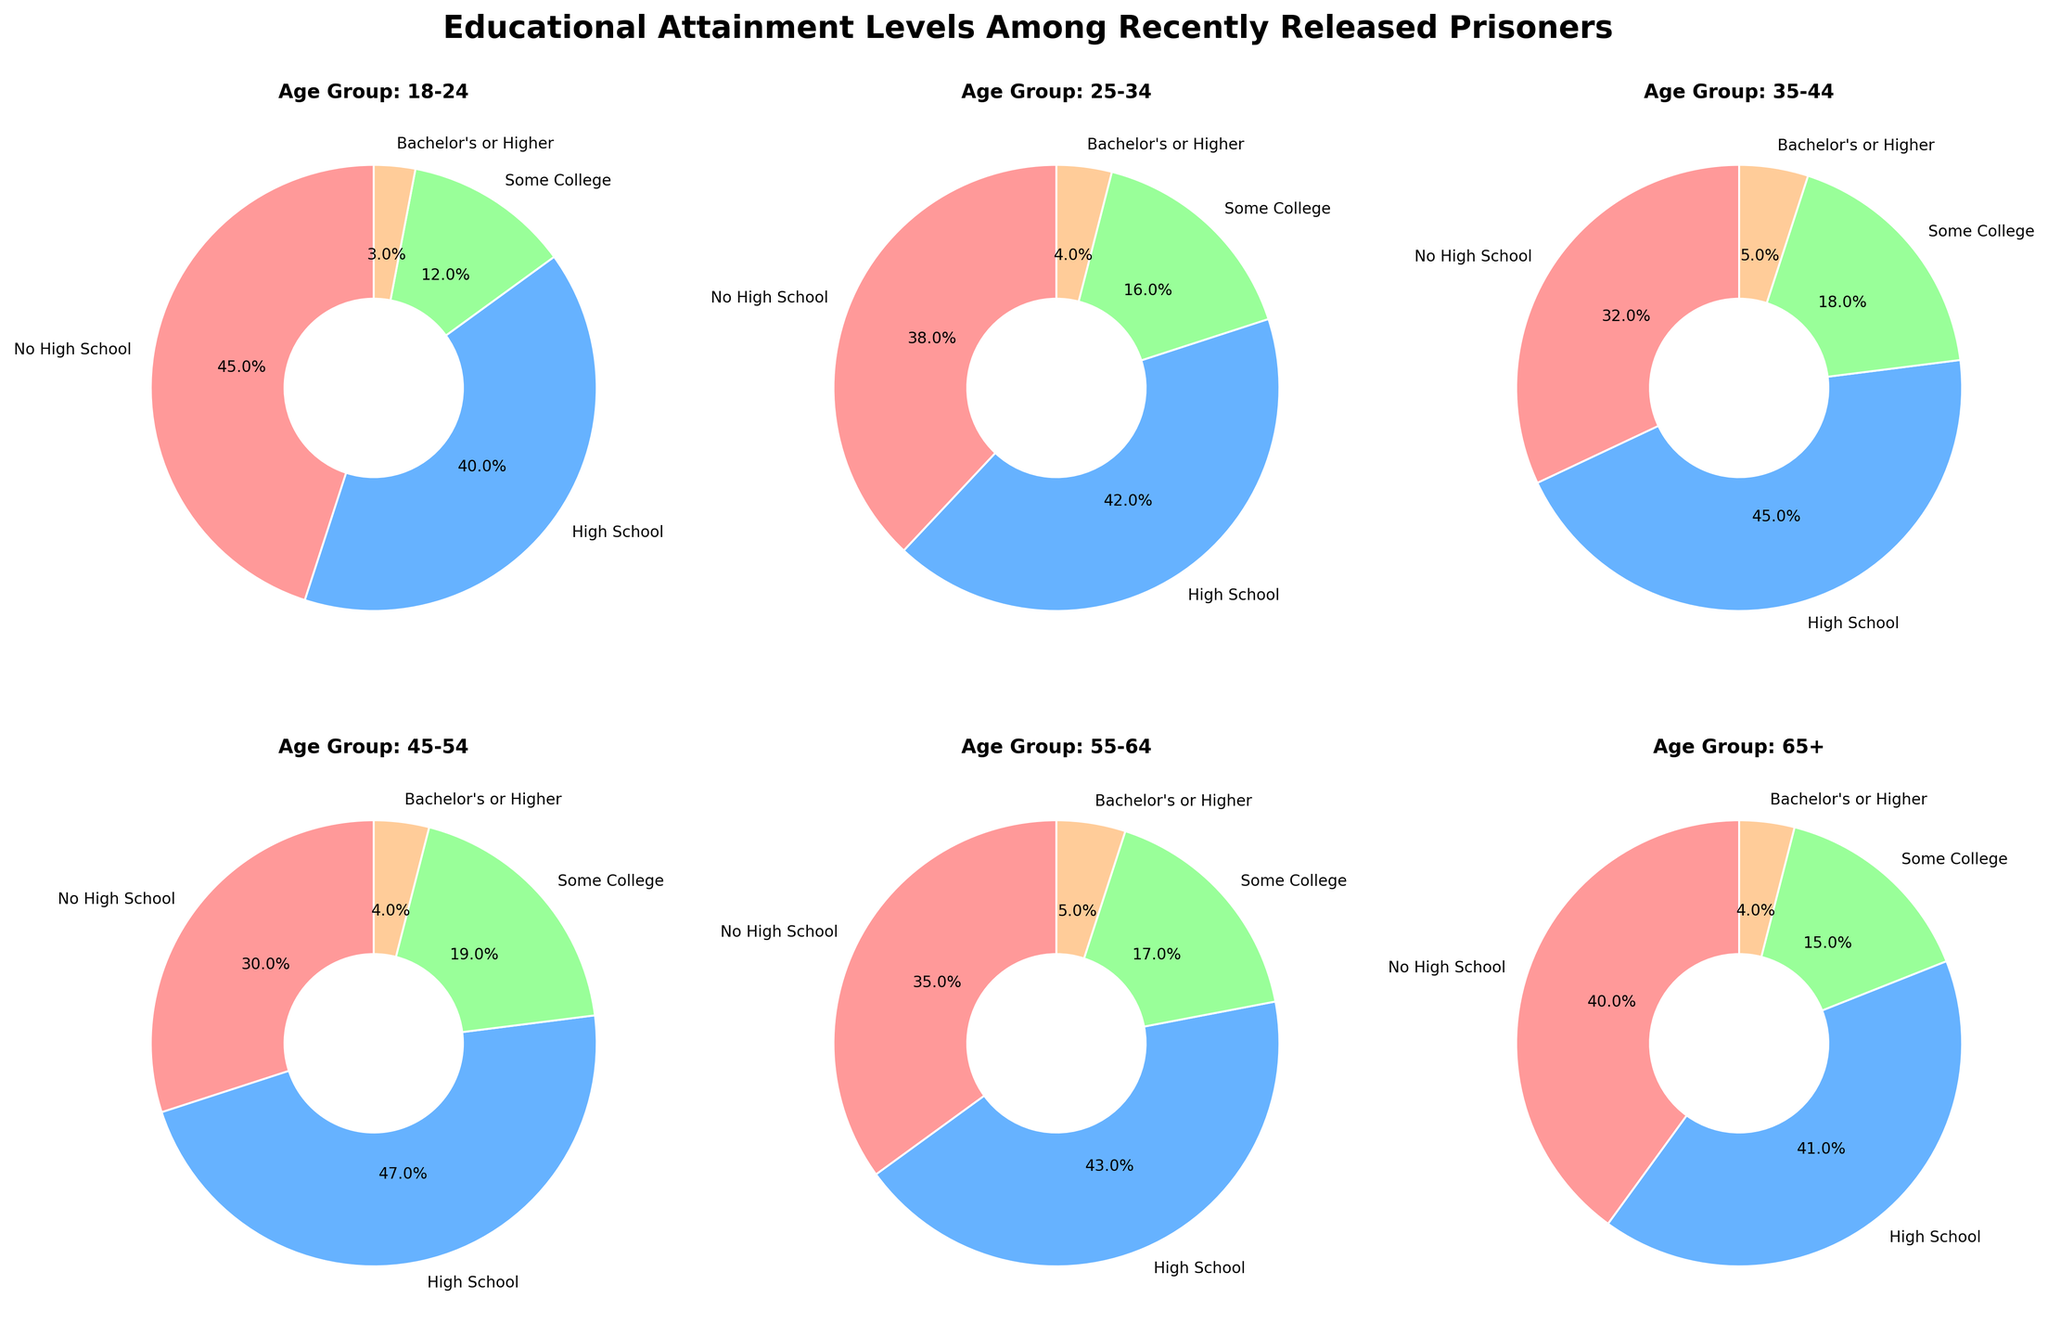Which age group has the highest percentage of individuals with a high school diploma? To answer this, look at each subplot and find the age group with the largest portion of the pie chart represented by the 'High School' category. The 45-54 age group has the largest slice.
Answer: 45-54 What percentage of the 18-24 age group has no high school education? Look at the pie chart for the 18-24 age group and find the portion labeled 'No High School'. The label indicates 45%.
Answer: 45% Compare the percentage of individuals with some college education between the 35-44 and 45-54 age groups. The 35-44 age group has 18% in the 'Some College' category, while the 45-54 age group has 19%.
Answer: 18% for 35-44 and 19% for 45-54 Which age group has the smallest percentage of individuals with a bachelor's degree or higher? Scan through each pie chart and compare the slices labeled 'Bachelor's or Higher'. Both the 18-24 and 25-34 age groups have the smallest slices with 3% and 4% respectively. The smallest is 3% for the 18-24 age group.
Answer: 18-24 What is the total percentage of individuals with at least some college education in the 55-64 age group? Sum the percentages of the 'Some College' and 'Bachelor's or Higher' categories for the 55-64 age group. This is 17% + 5% = 22%.
Answer: 22% Which age group has the most balanced distribution across all education levels? Look for the pie chart where the segment sizes are relatively even. The 18-24 age group has the most balanced distribution with 45%, 40%, 12%, and 3%.
Answer: 18-24 Are there any age groups where less than 30% of individuals have no high school education? Check each pie chart for the 'No High School' category to see which, if any, are less than 30%. None of the age groups have less than 30% in this category.
Answer: No Which age group shows the closest percentages between 'High School' and 'No High School'? Compare the 'High School' and 'No High School' slices in each pie chart to find the smallest difference. The 55-64 age group's difference between 'High School' (43%) and 'No High School' (35%) is 8%.
Answer: 55-64 What is the difference in the percentage of individuals with a bachelor's degree or higher between the 35-44 and 45-54 age groups? The 35-44 age group has 5% and the 45-54 age group has 4%, so the difference is 5% - 4% = 1%.
Answer: 1% Which age group has the highest combined percentage of people with at least a high school diploma? Add the percentages of 'High School', 'Some College', and 'Bachelor's or Higher' for each age group. The 35-44 age group has the highest combined percentage: 45% + 18% + 5% = 68%.
Answer: 35-44 